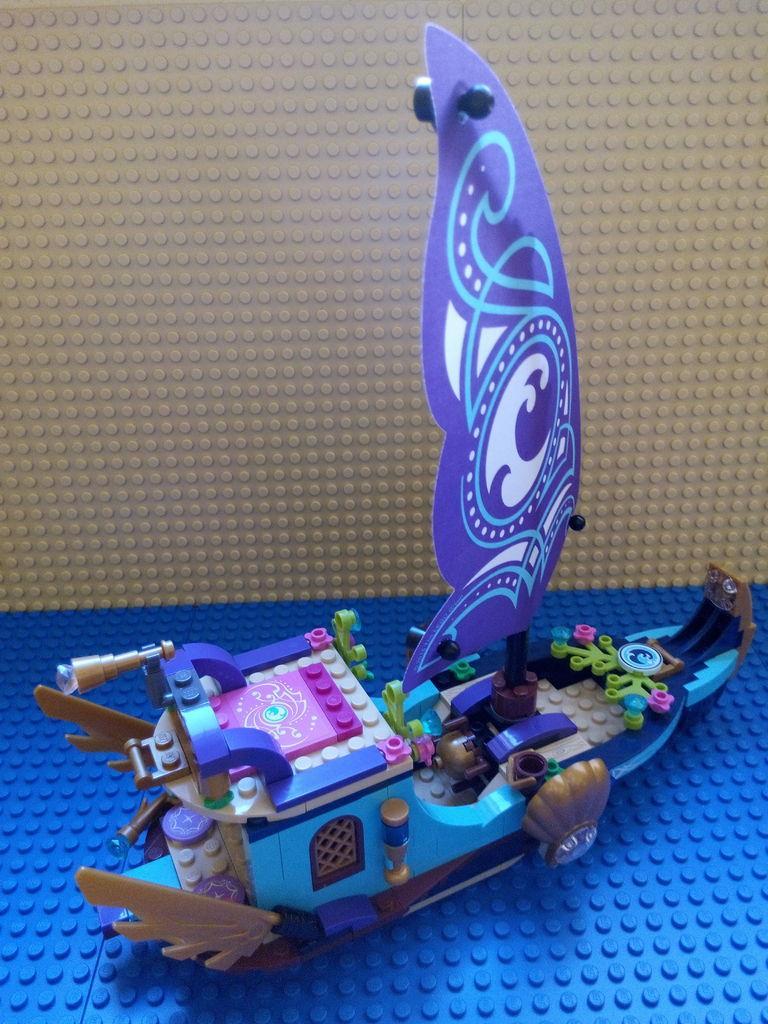Could you give a brief overview of what you see in this image? In this picture we can see the Lego. In the center there is an object which seems to be the toy boat and we can see some other toys. 